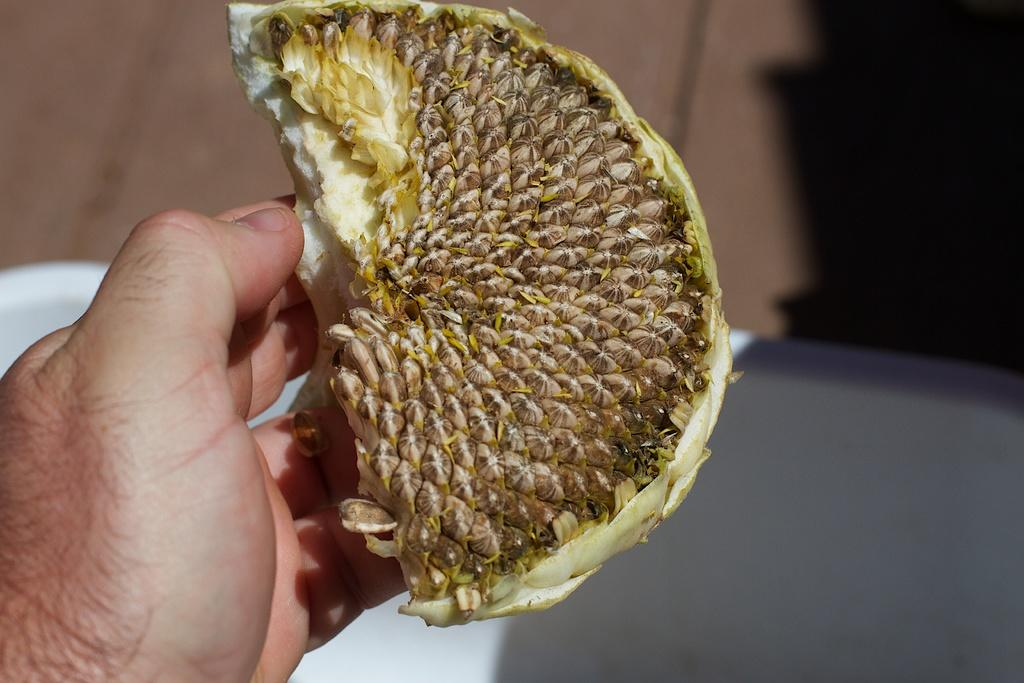What can be seen at the bottom left side of the image? There is a person's hand at the bottom left side of the image. What is the person holding in their hand? A fruit is present in the hand. What type of heart is visible in the image? There is no heart present in the image; it features a person's hand holding a fruit. 